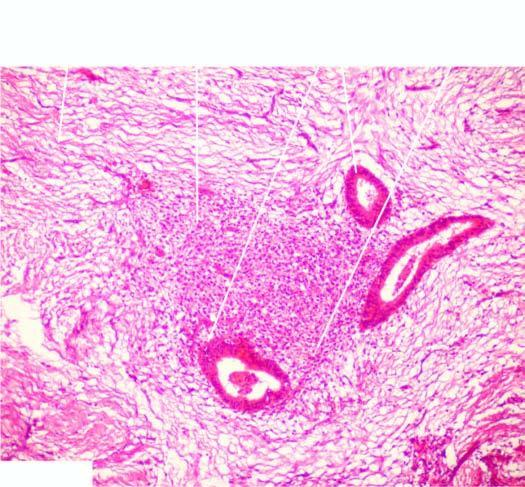does dense fibrocollagenic tissue contain endometrial glands, stroma and evidence of preceding old haemorrhage?
Answer the question using a single word or phrase. Yes 